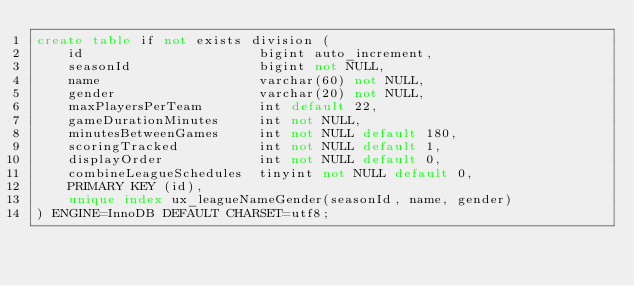Convert code to text. <code><loc_0><loc_0><loc_500><loc_500><_SQL_>create table if not exists division (
    id                      bigint auto_increment,
    seasonId                bigint not NULL,
    name                    varchar(60) not NULL,
    gender                  varchar(20) not NULL,
    maxPlayersPerTeam       int default 22,
    gameDurationMinutes     int not NULL,
    minutesBetweenGames     int not NULL default 180,
    scoringTracked          int not NULL default 1,
    displayOrder            int not NULL default 0,
    combineLeagueSchedules  tinyint not NULL default 0,
    PRIMARY KEY (id),
    unique index ux_leagueNameGender(seasonId, name, gender)
) ENGINE=InnoDB DEFAULT CHARSET=utf8;
</code> 